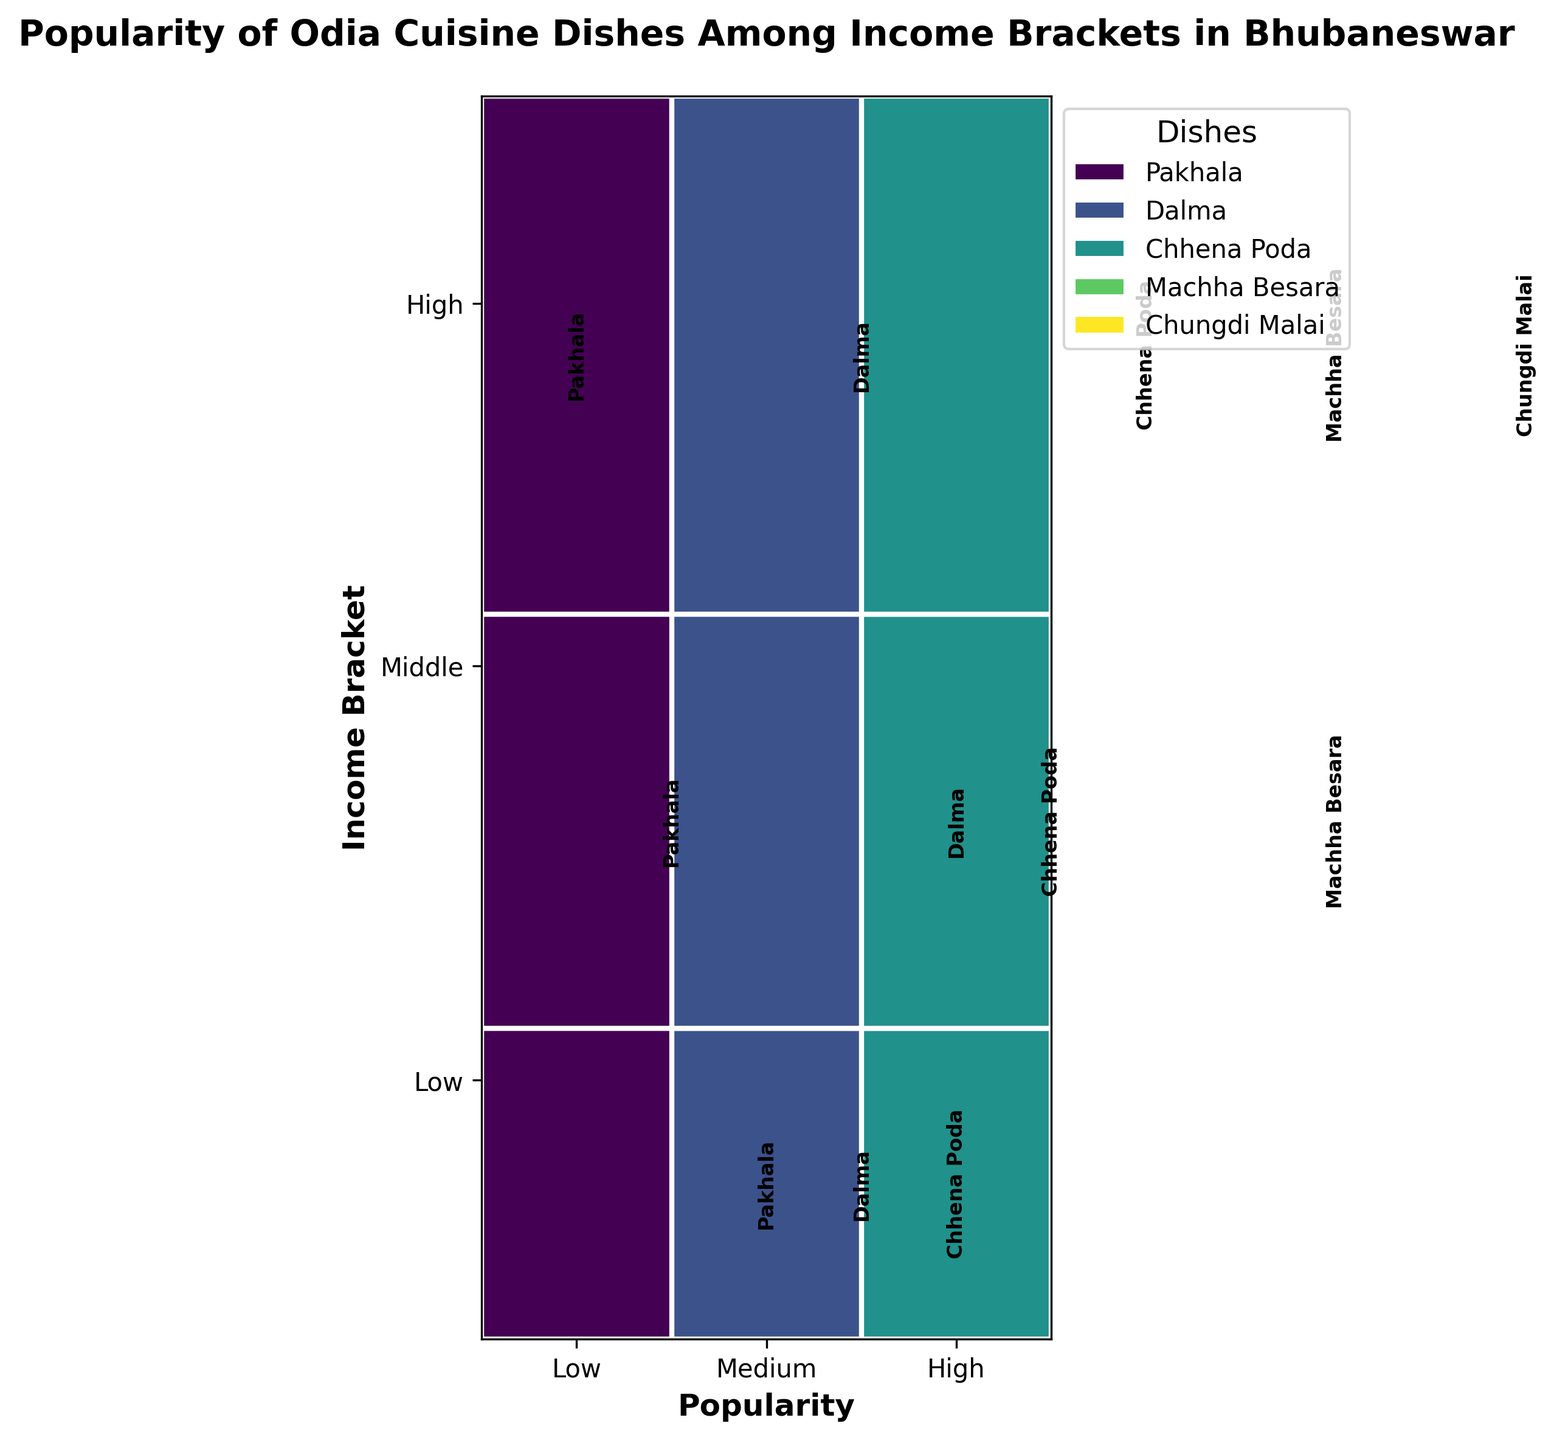What's the title of the figure? The title is usually displayed on top of the figure and it provides a quick summary about what the plot represents. The title in this plot is "Popularity of Odia Cuisine Dishes Among Income Brackets in Bhubaneswar" and it directly mentions both the dataset and the context.
Answer: Popularity of Odia Cuisine Dishes Among Income Brackets in Bhubaneswar Which dish is the most popular among the middle-income bracket? Look for the segment under the 'Middle' income level and note the dish associated with the tallest rectangle. 'Machha Besara' and 'Dalma' have the highest popularity in the middle-income bracket as their rectangles are the tallest.
Answer: Machha Besara, Dalma Which income bracket has the highest popularity for 'Chhena Poda'? Identify the segments corresponding to 'Chhena Poda' across all income brackets and compare their heights. The 'High' income bracket has the tallest rectangle for 'Chhena Poda'.
Answer: High How does the popularity of 'Pakhala' vary from low to high income brackets? Track the segments related to 'Pakhala' from low to high-income brackets. Notice that the height diminishes as you move from low to high income brackets indicating the popularity decreases from 'High' in the low bracket to 'Medium' in the middle bracket and 'Low' in the high bracket.
Answer: Decreases What is the least popular dish among the low-income bracket? For the low-income bracket, examine the smallest rectangle, which indicates the least popularity. 'Chhena Poda' has the smallest rectangle corresponding to low popularity.
Answer: Chhena Poda Is 'Dalma' more popular in the middle-income bracket compared to the high-income bracket? Compare the size of the 'Dalma' rectangles in both the middle and high-income segments. The middle-income bracket displays a higher rectangle for 'Dalma' compared to the high-income bracket.
Answer: Yes Do any dishes have equal popularity across multiple income brackets? Check if any dishes have rectangles of equal height across different income brackets. 'Chhena Poda' is the only dish with equal popularity across middle and high-income brackets, both with medium popularity.
Answer: Yes, Chhena Poda Which dish appears only in the high-income bracket? Identify dishes listed exclusively within the high-income bracket by checking the y-axis details. 'Chungdi Malai' only appears under the high-income bracket.
Answer: Chungdi Malai Which income bracket has the widest variety of dishes? Count the number of unique dishes within each income bracket. The high-income bracket has five different dishes, indicating the widest variety.
Answer: High How does the popularity of 'Machha Besara' compare between middle and high-income brackets? Compare the rectangles for 'Machha Besara' under both middle and high-income. Both brackets show 'High' popularity with comparable heights.
Answer: Equal 